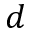Convert formula to latex. <formula><loc_0><loc_0><loc_500><loc_500>d</formula> 